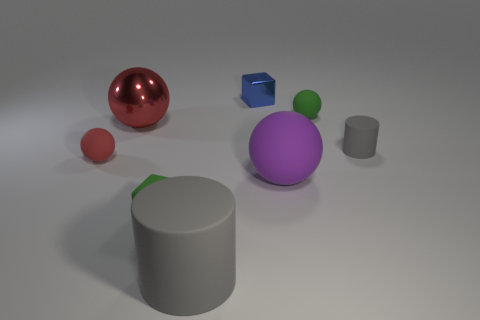Add 2 purple metallic blocks. How many objects exist? 10 Subtract all rubber spheres. How many spheres are left? 1 Subtract all purple balls. How many balls are left? 3 Subtract all cylinders. How many objects are left? 6 Subtract all gray spheres. Subtract all cyan cylinders. How many spheres are left? 4 Subtract all tiny green matte things. Subtract all big shiny things. How many objects are left? 5 Add 8 purple things. How many purple things are left? 9 Add 3 big metallic spheres. How many big metallic spheres exist? 4 Subtract 1 blue cubes. How many objects are left? 7 